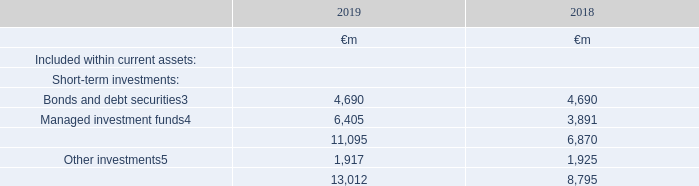Current other investments comprise the following:
The Group invests surplus cash positions across a portfolio of short-term investments to manage liquidity and credit risk whilst achieving suitable returns. These assets do not meet the definition of cash and cash equivalents, but are included in the Group’s net debt based on their liquidity.
Bonds and debt securities includes €955 million (2018: €862 million) of highly liquid German and €941 million (2018: €nil) Japanese government securities; €1,115 million (2018: €1,112 million) of UK government bonds and €1,184 million (2018: 830 million) of other assets both paid as collateral on derivative financial instruments6. Managed investment funds include €5,513 million (2018: €3,087 million) in managed investment funds with liquidity of up to 90 days and €892 million (2018: €804 million) invested in a fund whose underlying securities are supply chain receivables from a diverse range of corporate organisations of which Vodafone is a minority constituent.
Other investments are excluded from net debt based on their liquidity and primarily consist of restricted debt securities including amounts held in qualifying assets by Group insurance companies to meet regulatory requirements.
3 €1,184 million (2018: €830 million) is measured at amortised cost and remaining items are measured at fair value. For €3,011 million (2018: €1,974 million) the valuation basis is level 1 classification, which comprises financial instruments where fair value is determined by unadjusted quoted prices in active markets for identical assets or liabilities. The remaining balance is level 2 classification.
4 Items measured at fair value and the valuation basis is level 2 classification
5 €1,097 million (2018: €487 million) is measured at fair value and the valuation basis is level 1. The remaining items are measured at amortised cost and the carrying amount approximates fair value
Which financial years' information is shown in the table? 2018, 2019. What type of short-term investments are shown in the table? Bonds and debt securities, managed investment funds. What is the total value of short-term investments in 2019?
Answer scale should be: million. 11,095. What percentage of 2019 Bonds and debt securities is the 2019 highly liquid German government securities?
Answer scale should be: percent. 955/4,690
Answer: 20.36. What percentage of 2019 Bonds and debt securities is the 2019 Japanese government securities?
Answer scale should be: percent. 941/4,690
Answer: 20.06. What is the change in managed investment funds between 2018 and 2019?
Answer scale should be: million. 6,405-3,891
Answer: 2514. 